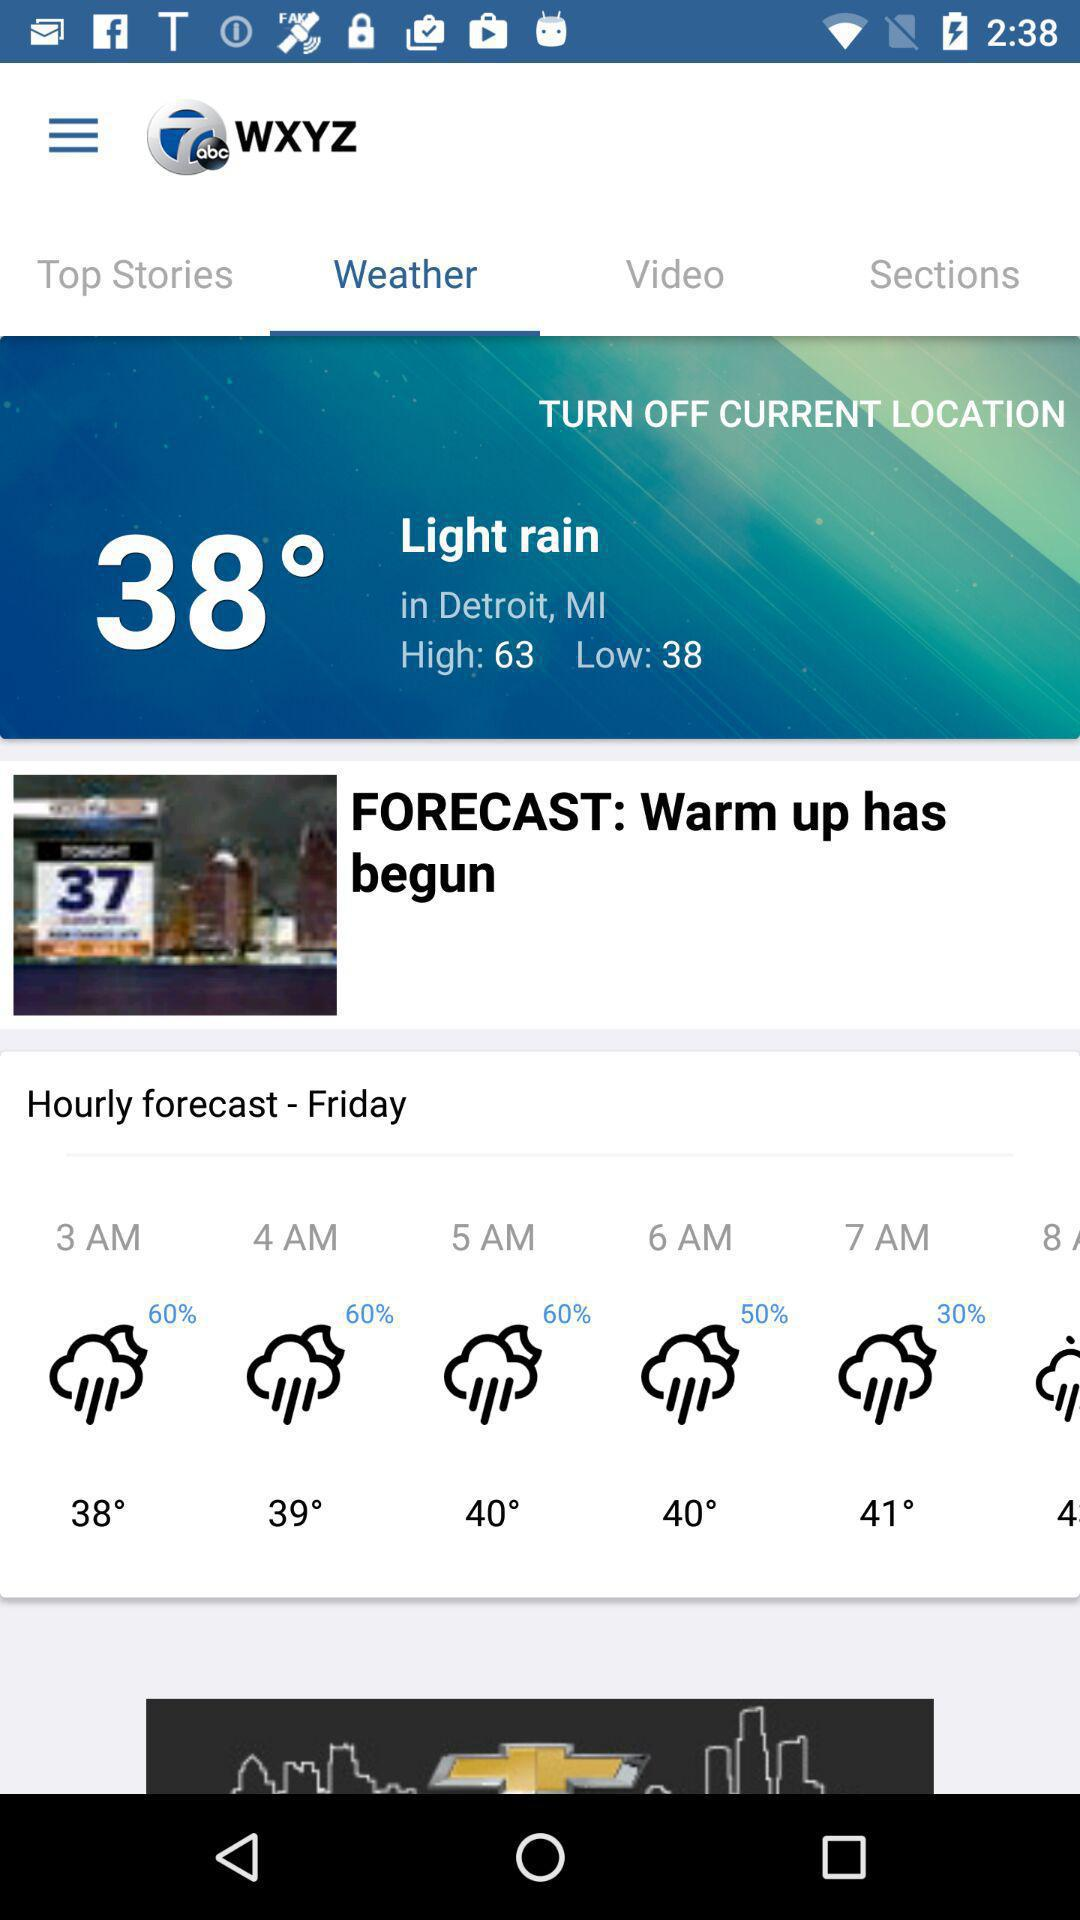Which tab is selected in the "WXYZ"? The selected tab is "Weather". 